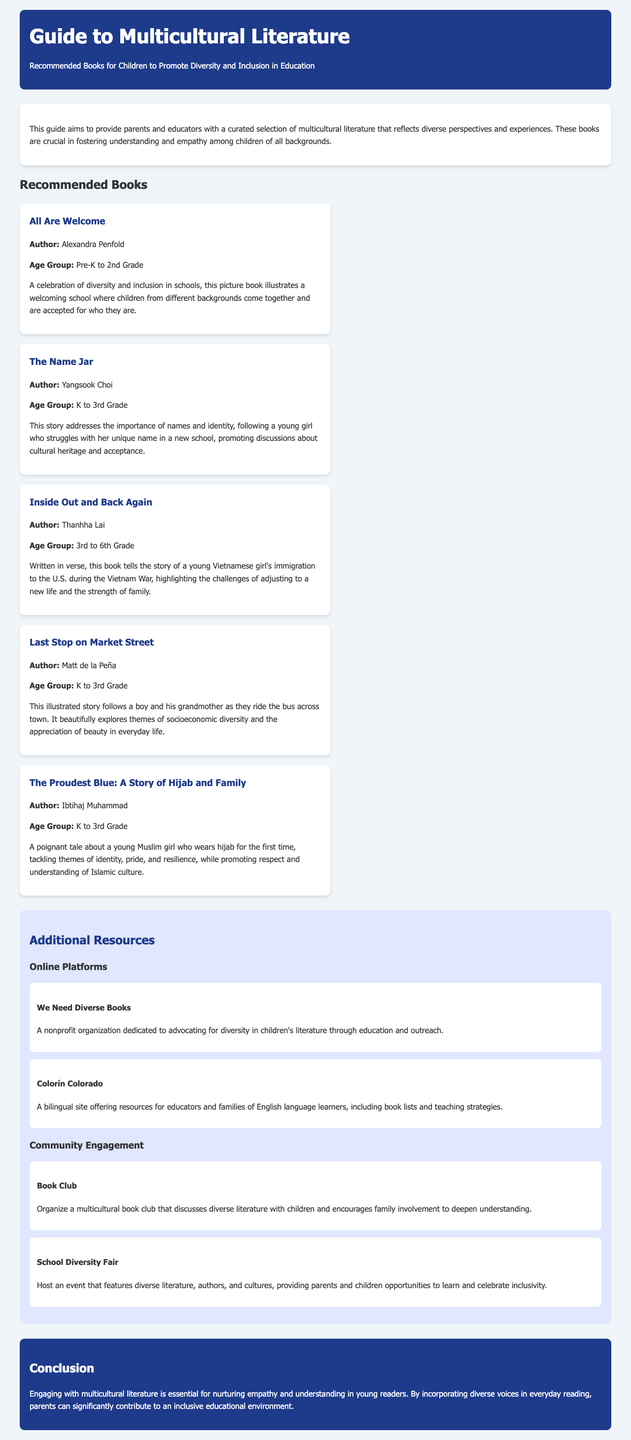What is the title of the guide? The title of the guide is presented at the top of the document, which is "Guide to Multicultural Literature".
Answer: Guide to Multicultural Literature Who is the author of "The Name Jar"? The author's name is mentioned in the book's description, which is "Yangsook Choi".
Answer: Yangsook Choi What age group is "All Are Welcome" recommended for? The recommended age group is provided in the book description, which states "Pre-K to 2nd Grade".
Answer: Pre-K to 2nd Grade What is the main theme of "Last Stop on Market Street"? The main theme is given in the book description as it "beautifully explores themes of socioeconomic diversity".
Answer: Socioeconomic diversity What organization is dedicated to advocating for diversity in children's literature? The document lists the organization and its purpose, which is "We Need Diverse Books".
Answer: We Need Diverse Books What community engagement activity is suggested in the document? The document mentions an activity that facilitates engagement, which is "School Diversity Fair".
Answer: School Diversity Fair How many recommended books are listed in the document? The document enumerates the books provided under the "Recommended Books" section, totaling "five books".
Answer: Five books What is the conclusion about engaging with multicultural literature? The conclusion summarizes the importance, stating it is "essential for nurturing empathy and understanding in young readers".
Answer: Essential for nurturing empathy and understanding in young readers What is the subtitle of the guide? The subtitle is indicated immediately under the main title, which reads "Recommended Books for Children to Promote Diversity and Inclusion in Education".
Answer: Recommended Books for Children to Promote Diversity and Inclusion in Education 